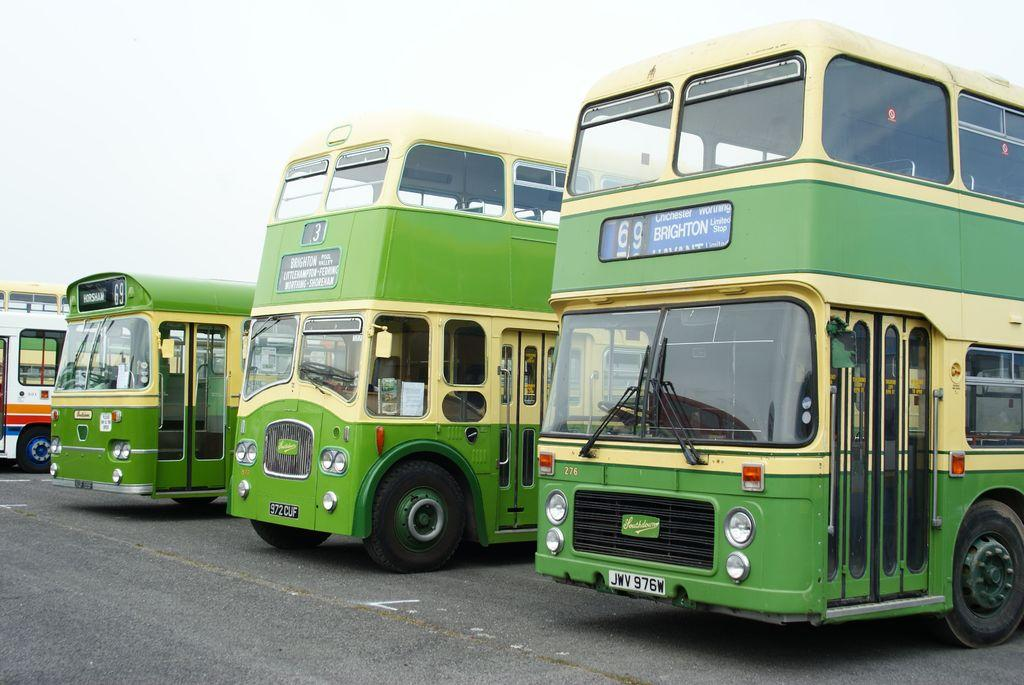<image>
Provide a brief description of the given image. A green and yellow bus with 69 Brighton on it. 